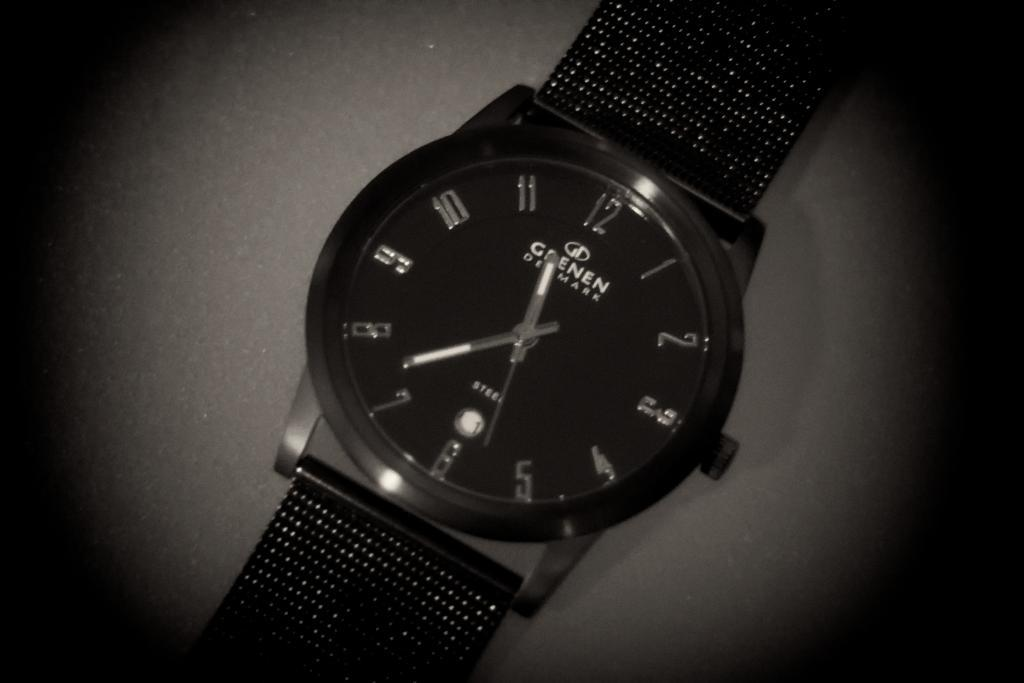<image>
Give a short and clear explanation of the subsequent image. A Grenen Denmark watch has a time of about 11:37. 